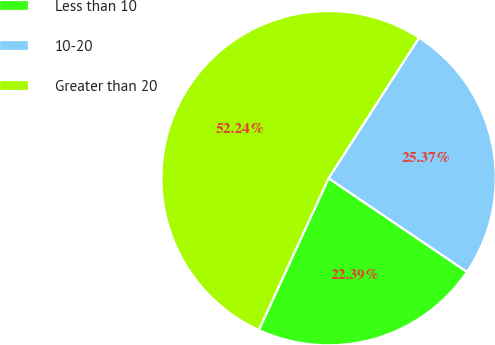Convert chart to OTSL. <chart><loc_0><loc_0><loc_500><loc_500><pie_chart><fcel>Less than 10<fcel>10-20<fcel>Greater than 20<nl><fcel>22.39%<fcel>25.37%<fcel>52.24%<nl></chart> 